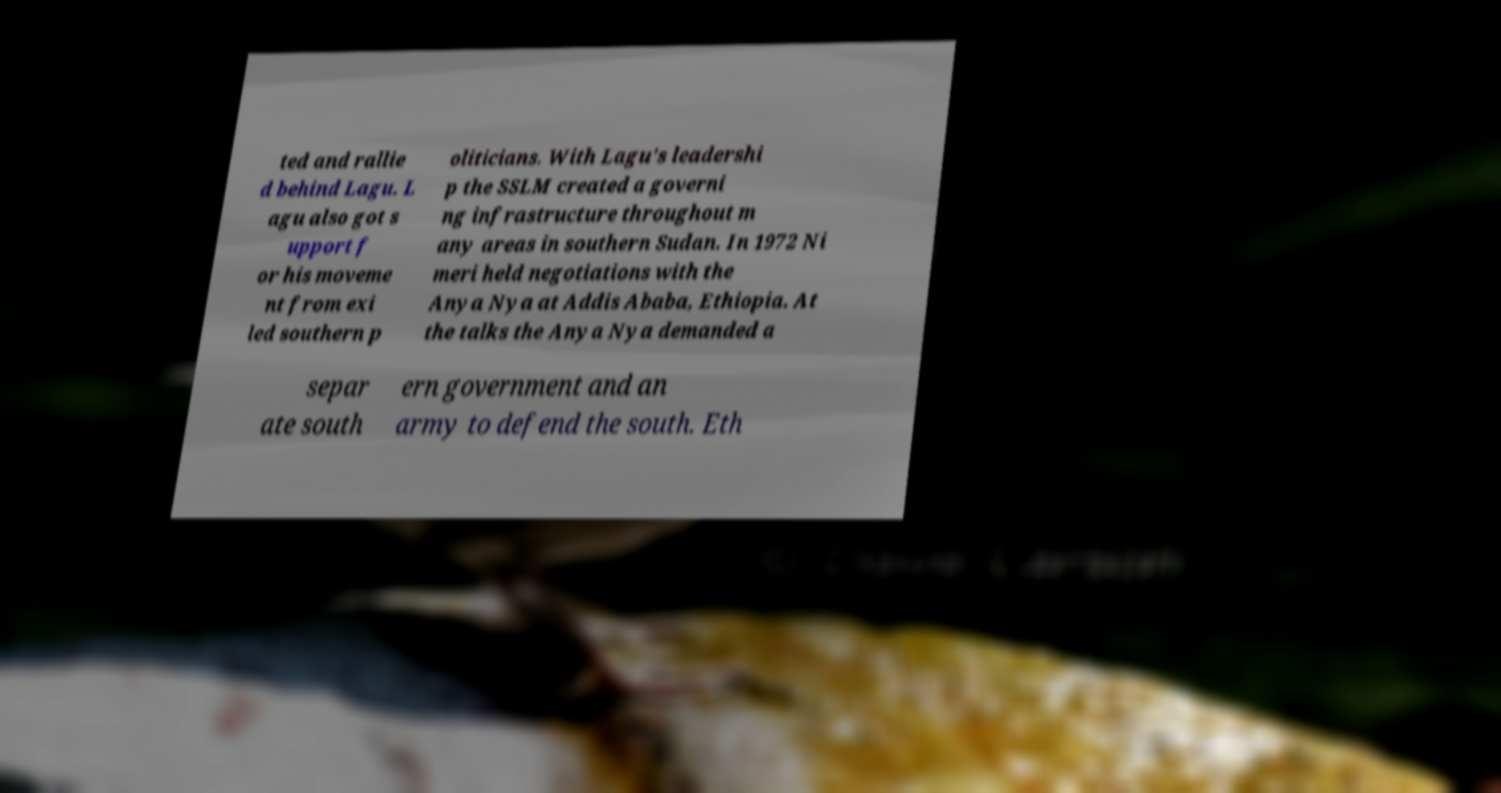There's text embedded in this image that I need extracted. Can you transcribe it verbatim? ted and rallie d behind Lagu. L agu also got s upport f or his moveme nt from exi led southern p oliticians. With Lagu's leadershi p the SSLM created a governi ng infrastructure throughout m any areas in southern Sudan. In 1972 Ni meri held negotiations with the Anya Nya at Addis Ababa, Ethiopia. At the talks the Anya Nya demanded a separ ate south ern government and an army to defend the south. Eth 